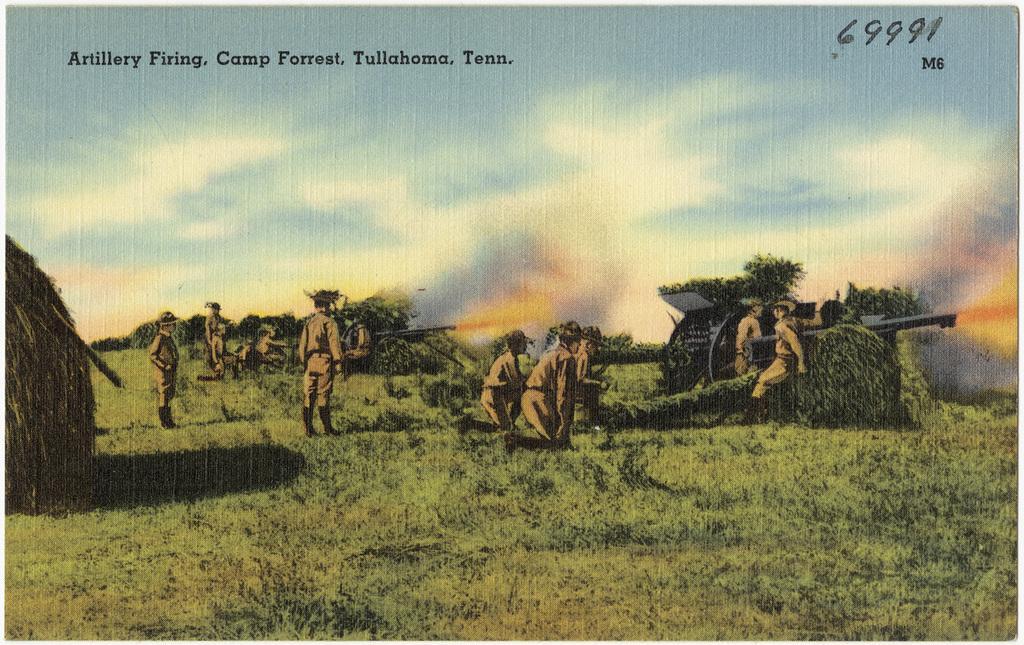How would you summarize this image in a sentence or two? In this image I can see few persons wearing uniforms are standing. I can see weapons, Trees, Grass and the sky in the background. 